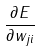Convert formula to latex. <formula><loc_0><loc_0><loc_500><loc_500>\frac { \partial E } { \partial w _ { j i } }</formula> 